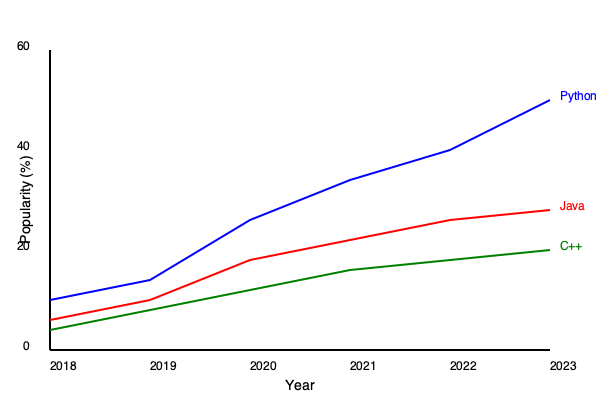Based on the programming language popularity trends shown in the graph, which language has experienced the most significant increase in popularity from 2018 to 2023, and approximately what percentage point increase does this represent? To answer this question, we need to follow these steps:

1. Identify the three programming languages represented in the graph:
   - Blue line: Python
   - Red line: Java
   - Green line: C++

2. Observe the trend for each language from 2018 to 2023:
   - Python: Shows a steep upward trend
   - Java: Shows a gradual downward trend
   - C++: Shows a slight downward trend

3. Determine which language has the most significant increase:
   - Python is the only language showing an increase, making it the correct answer.

4. Calculate the approximate percentage point increase for Python:
   - In 2018 (leftmost point), Python's popularity is around 10%
   - In 2023 (rightmost point), Python's popularity is around 50%
   - Percentage point increase: 50% - 10% = 40 percentage points

Therefore, Python has experienced the most significant increase in popularity, with an approximate 40 percentage point increase from 2018 to 2023.
Answer: Python, 40 percentage points 